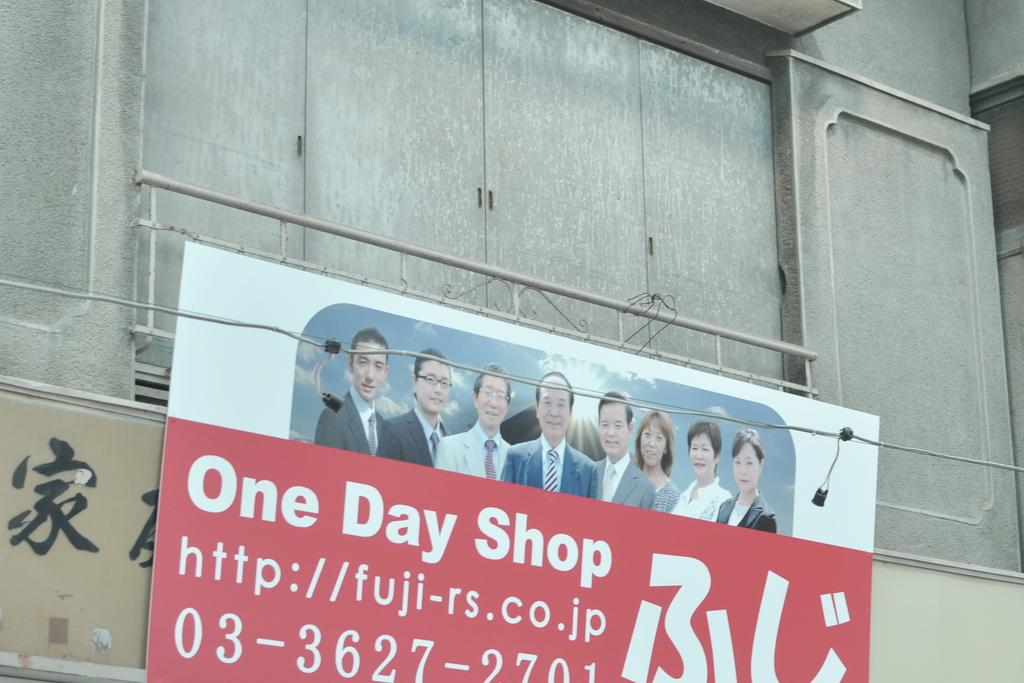<image>
Provide a brief description of the given image. A sign hanging outside a concrete building that reads One Day shop. 